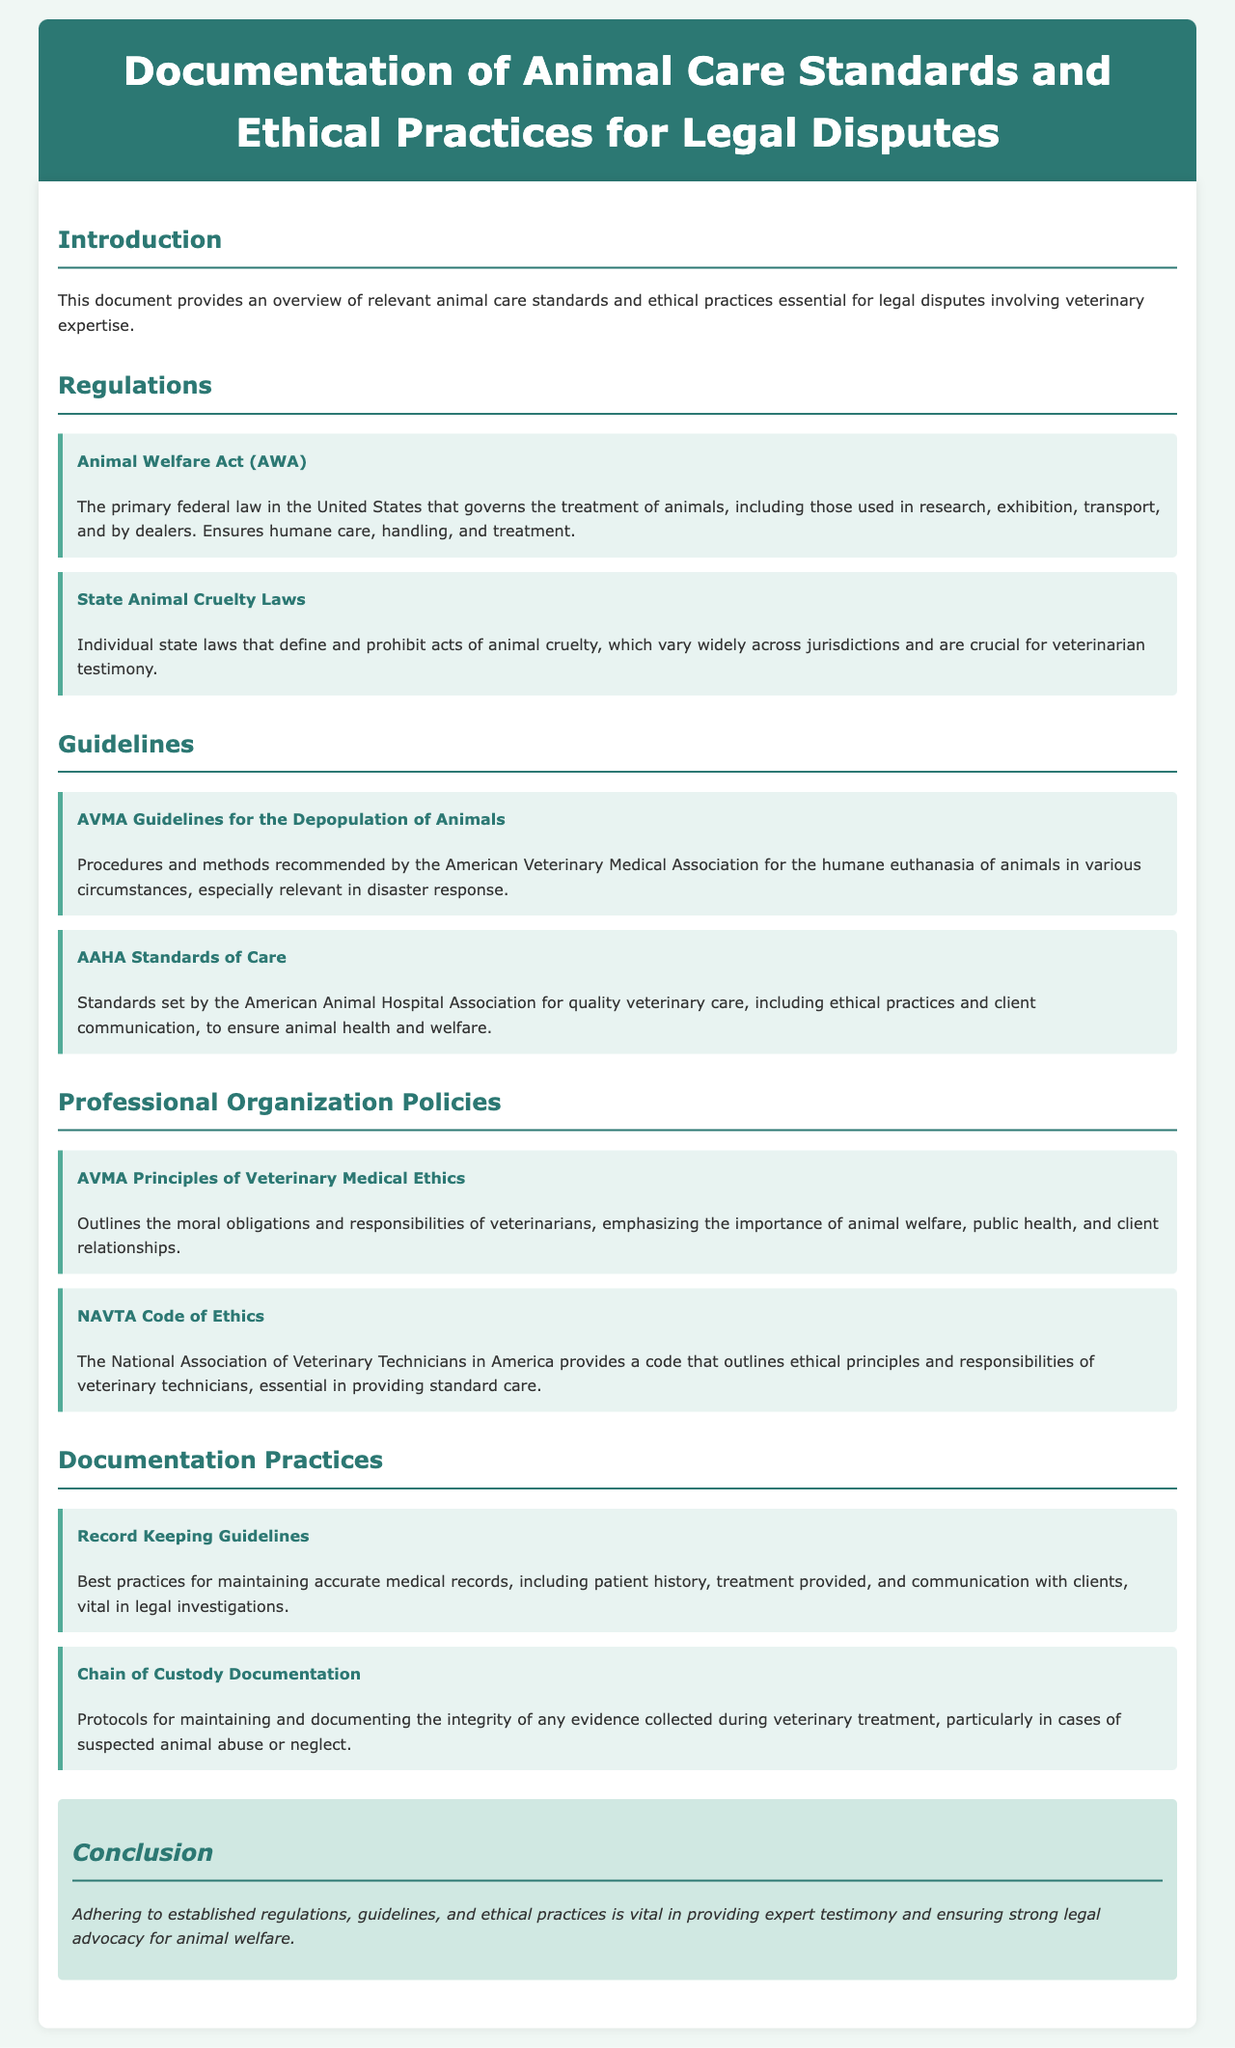What is the primary federal law governing animal treatment? The document mentions the Animal Welfare Act (AWA) as the primary federal law in the United States governing the treatment of animals.
Answer: Animal Welfare Act (AWA) What does AAHA stand for? The acronym AAHA in the document refers to the American Animal Hospital Association, which sets standards for veterinary care.
Answer: American Animal Hospital Association What is a key aspect of the AVMA Guidelines for Depopulation of Animals? The guidelines recommend procedures and methods for humane euthanasia of animals in various circumstances.
Answer: Humane euthanasia What do the AVMA Principles of Veterinary Medical Ethics emphasize? The document states that these principles emphasize the importance of animal welfare, public health, and client relationships.
Answer: Animal welfare What documentation practice is vital in legal investigations? The document highlights that record keeping guidelines are vital for maintaining accurate medical records.
Answer: Record keeping guidelines What do state laws define regarding animal care? According to the document, state animal cruelty laws define and prohibit acts of animal cruelty, which vary by jurisdiction.
Answer: Acts of animal cruelty What is essential in maintaining evidence during veterinary treatment? The document mentions that chain of custody documentation is crucial for maintaining the integrity of evidence collected.
Answer: Chain of custody documentation What does NAVTA stand for? The abbreviation NAVTA in the document refers to the National Association of Veterinary Technicians in America.
Answer: National Association of Veterinary Technicians in America What is the focus of the conclusion section? The conclusion emphasizes adhering to established regulations, guidelines, and ethical practices for expert testimony.
Answer: Regulations, guidelines, and ethical practices 